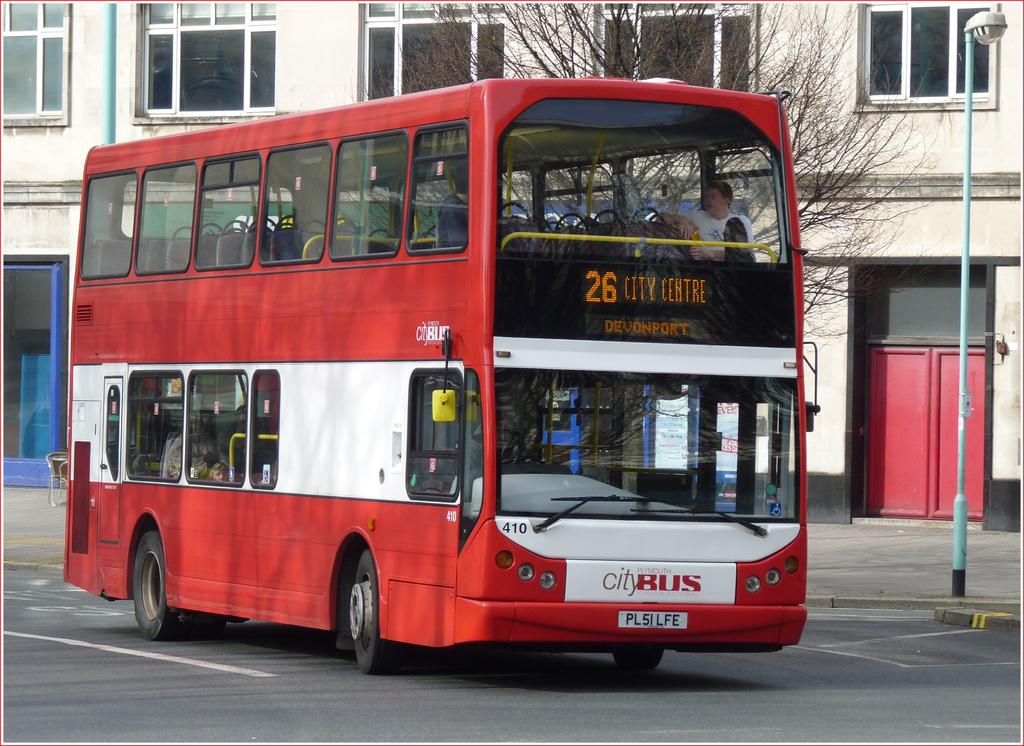<image>
Summarize the visual content of the image. A doubledecker bus that stops at 26 City Centre. 